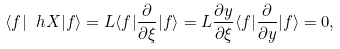<formula> <loc_0><loc_0><loc_500><loc_500>\langle f | \ h X | f \rangle = L \langle f | \frac { \partial } { \partial \xi } | f \rangle = L \frac { \partial y } { \partial \xi } \langle f | \frac { \partial } { \partial y } | f \rangle = 0 ,</formula> 